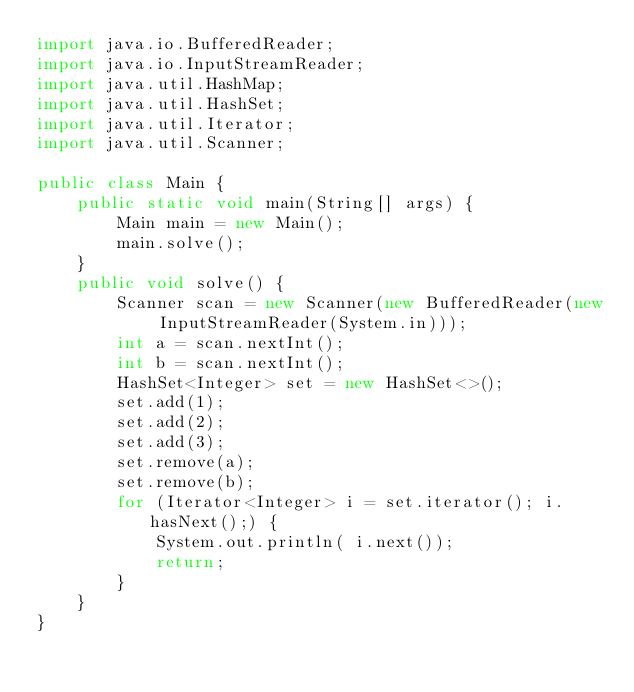Convert code to text. <code><loc_0><loc_0><loc_500><loc_500><_Java_>import java.io.BufferedReader;
import java.io.InputStreamReader;
import java.util.HashMap;
import java.util.HashSet;
import java.util.Iterator;
import java.util.Scanner;

public class Main {
    public static void main(String[] args) {
        Main main = new Main();
        main.solve();
    }
    public void solve() {
        Scanner scan = new Scanner(new BufferedReader(new InputStreamReader(System.in)));
        int a = scan.nextInt();
        int b = scan.nextInt();
        HashSet<Integer> set = new HashSet<>();
        set.add(1);
        set.add(2);
        set.add(3);
        set.remove(a);
        set.remove(b);
        for (Iterator<Integer> i = set.iterator(); i.hasNext();) {
            System.out.println( i.next());
            return;
        }
    }
}
</code> 